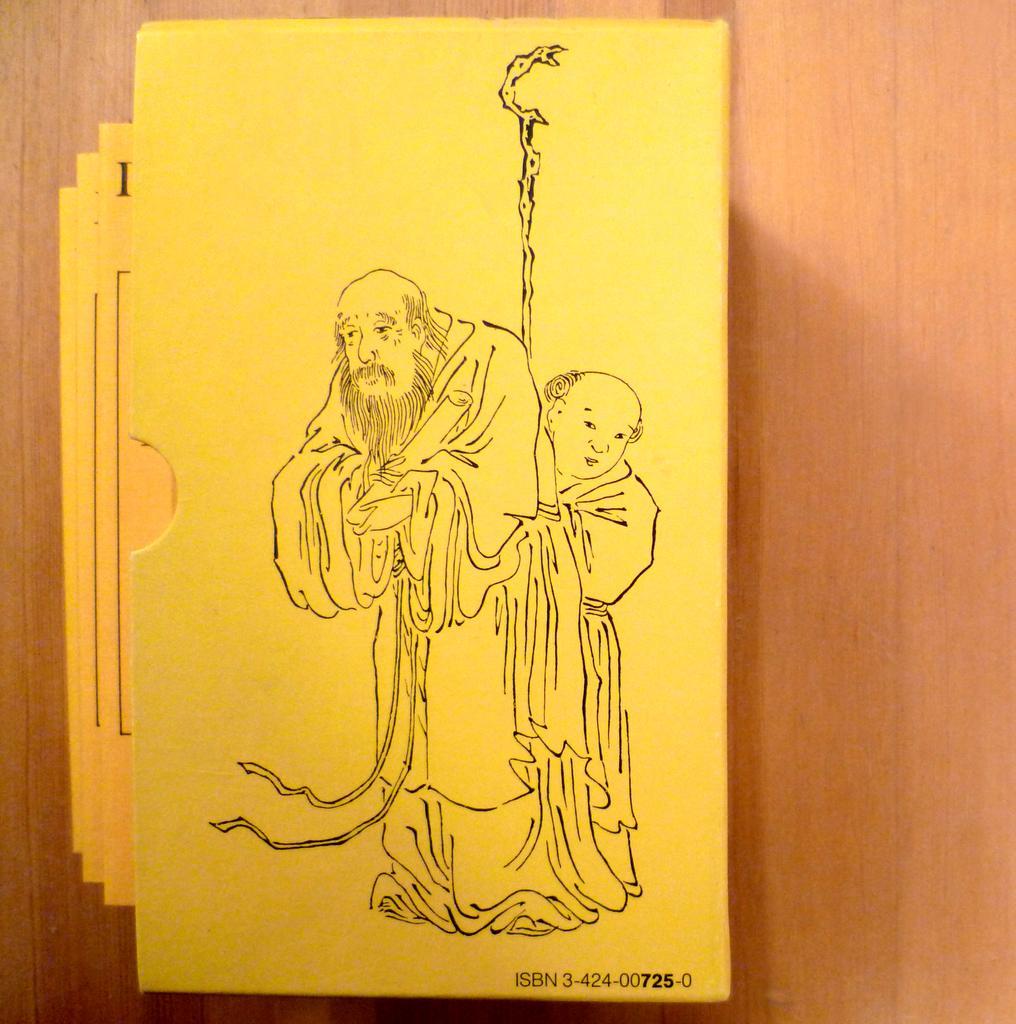In one or two sentences, can you explain what this image depicts? This picture looks like a envelope and I can see few cards in it and I can see picture on the envelope and looks like a table in the background. 